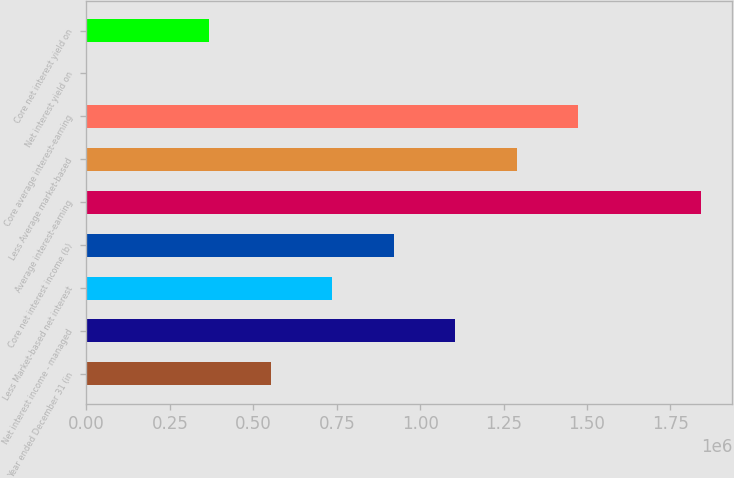Convert chart to OTSL. <chart><loc_0><loc_0><loc_500><loc_500><bar_chart><fcel>Year ended December 31 (in<fcel>Net interest income - managed<fcel>Less Market-based net interest<fcel>Core net interest income (b)<fcel>Average interest-earning<fcel>Less Average market-based<fcel>Core average interest-earning<fcel>Net interest yield on<fcel>Core net interest yield on<nl><fcel>552726<fcel>1.10545e+06<fcel>736967<fcel>921209<fcel>1.84242e+06<fcel>1.28969e+06<fcel>1.47393e+06<fcel>1.16<fcel>368484<nl></chart> 